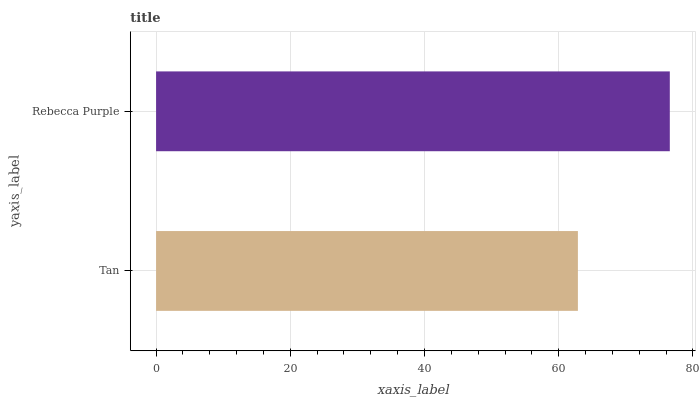Is Tan the minimum?
Answer yes or no. Yes. Is Rebecca Purple the maximum?
Answer yes or no. Yes. Is Rebecca Purple the minimum?
Answer yes or no. No. Is Rebecca Purple greater than Tan?
Answer yes or no. Yes. Is Tan less than Rebecca Purple?
Answer yes or no. Yes. Is Tan greater than Rebecca Purple?
Answer yes or no. No. Is Rebecca Purple less than Tan?
Answer yes or no. No. Is Rebecca Purple the high median?
Answer yes or no. Yes. Is Tan the low median?
Answer yes or no. Yes. Is Tan the high median?
Answer yes or no. No. Is Rebecca Purple the low median?
Answer yes or no. No. 